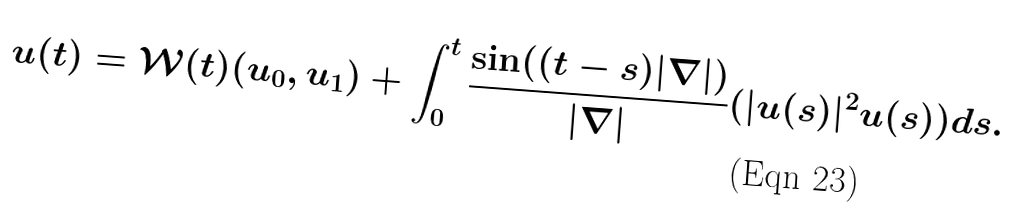<formula> <loc_0><loc_0><loc_500><loc_500>u ( t ) = \mathcal { W } ( t ) ( u _ { 0 } , u _ { 1 } ) + \int _ { 0 } ^ { t } \frac { \sin ( ( t - s ) | \nabla | ) } { | \nabla | } ( | u ( s ) | ^ { 2 } u ( s ) ) d s .</formula> 